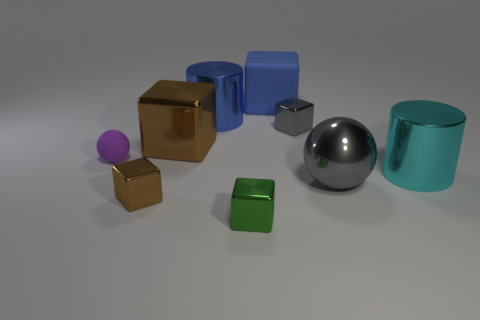There is a large block that is right of the big block that is on the left side of the green cube; what is it made of?
Make the answer very short. Rubber. There is a shiny cylinder that is behind the purple ball; what size is it?
Your answer should be very brief. Large. How many blue objects are tiny matte balls or large metal cylinders?
Provide a short and direct response. 1. There is a large blue thing that is the same shape as the green thing; what is its material?
Provide a short and direct response. Rubber. Are there the same number of tiny brown metallic cubes in front of the large blue block and tiny brown blocks?
Provide a succinct answer. Yes. What size is the shiny block that is both to the right of the blue metallic thing and left of the gray metallic cube?
Provide a succinct answer. Small. Are there any other things that are the same color as the big shiny block?
Provide a short and direct response. Yes. How big is the rubber thing that is right of the sphere left of the blue matte thing?
Provide a short and direct response. Large. There is a small object that is both behind the big gray sphere and to the left of the large metal block; what color is it?
Give a very brief answer. Purple. What number of other objects are there of the same size as the gray cube?
Ensure brevity in your answer.  3. 